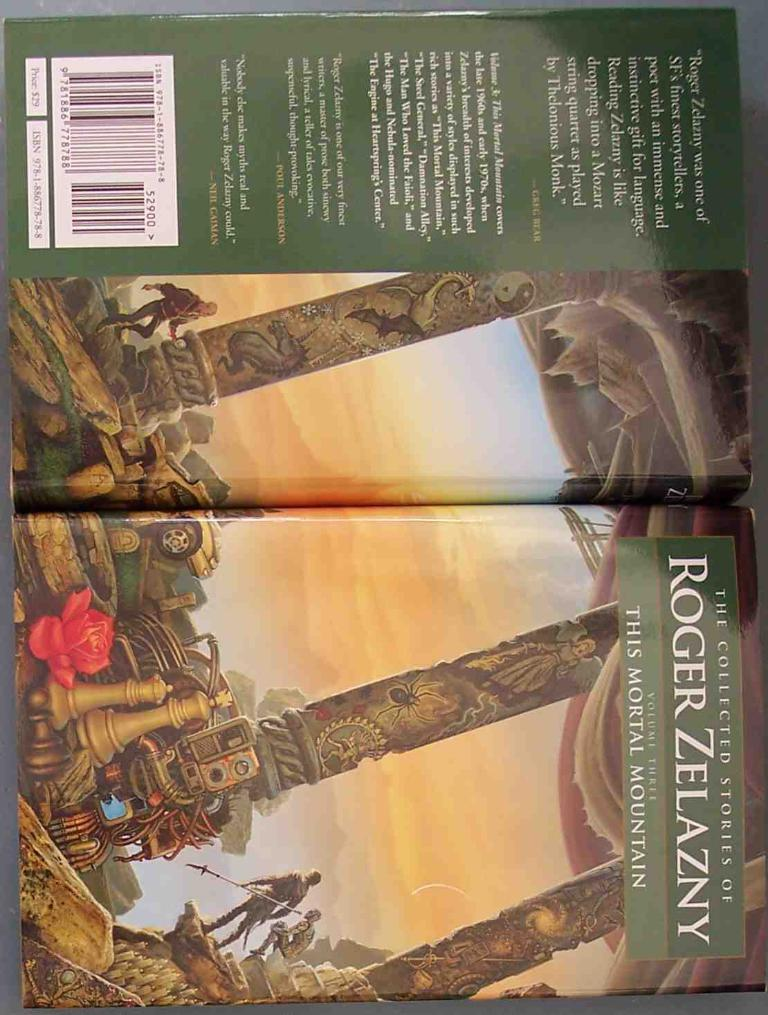<image>
Write a terse but informative summary of the picture. a book cover that is by roger zelazny and is called the mortal mountain 